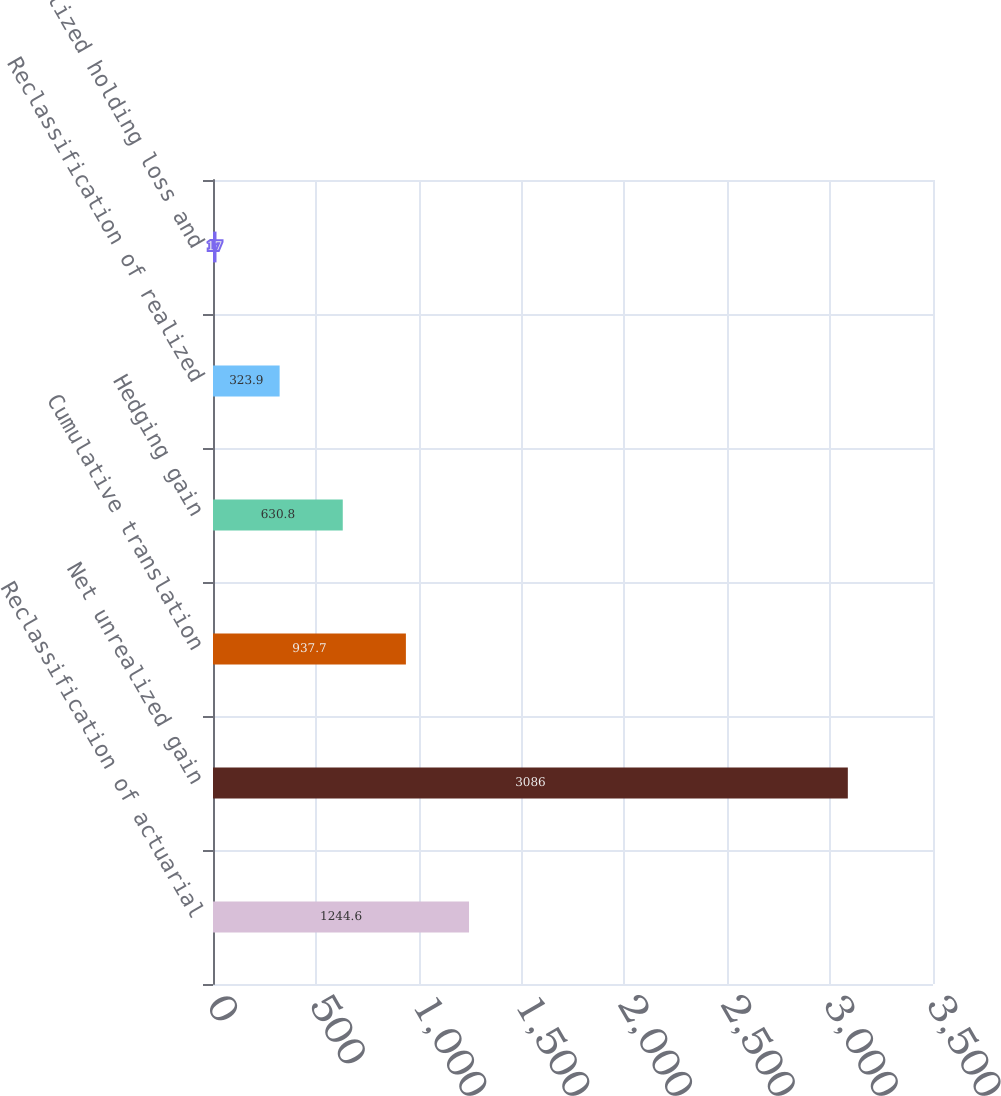<chart> <loc_0><loc_0><loc_500><loc_500><bar_chart><fcel>Reclassification of actuarial<fcel>Net unrealized gain<fcel>Cumulative translation<fcel>Hedging gain<fcel>Reclassification of realized<fcel>Unrealized holding loss and<nl><fcel>1244.6<fcel>3086<fcel>937.7<fcel>630.8<fcel>323.9<fcel>17<nl></chart> 